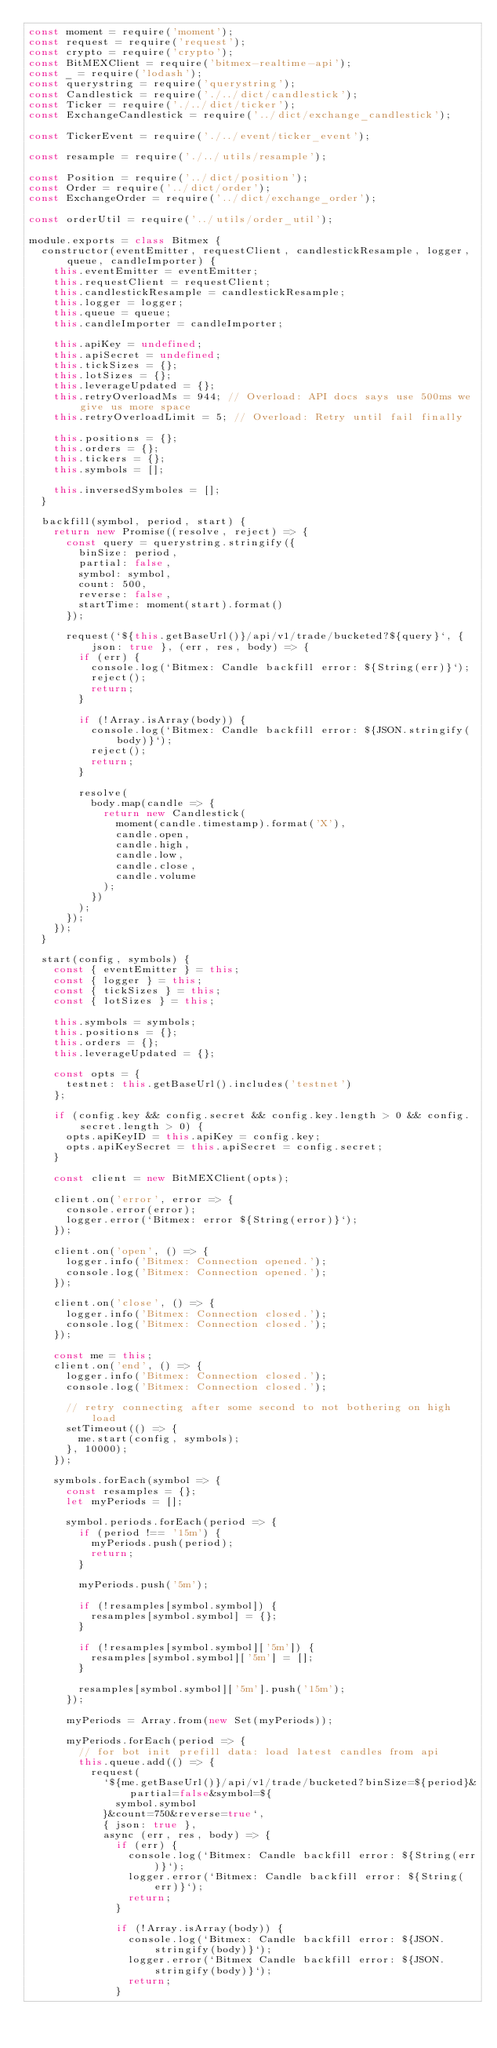Convert code to text. <code><loc_0><loc_0><loc_500><loc_500><_JavaScript_>const moment = require('moment');
const request = require('request');
const crypto = require('crypto');
const BitMEXClient = require('bitmex-realtime-api');
const _ = require('lodash');
const querystring = require('querystring');
const Candlestick = require('./../dict/candlestick');
const Ticker = require('./../dict/ticker');
const ExchangeCandlestick = require('../dict/exchange_candlestick');

const TickerEvent = require('./../event/ticker_event');

const resample = require('./../utils/resample');

const Position = require('../dict/position');
const Order = require('../dict/order');
const ExchangeOrder = require('../dict/exchange_order');

const orderUtil = require('../utils/order_util');

module.exports = class Bitmex {
  constructor(eventEmitter, requestClient, candlestickResample, logger, queue, candleImporter) {
    this.eventEmitter = eventEmitter;
    this.requestClient = requestClient;
    this.candlestickResample = candlestickResample;
    this.logger = logger;
    this.queue = queue;
    this.candleImporter = candleImporter;

    this.apiKey = undefined;
    this.apiSecret = undefined;
    this.tickSizes = {};
    this.lotSizes = {};
    this.leverageUpdated = {};
    this.retryOverloadMs = 944; // Overload: API docs says use 500ms we give us more space
    this.retryOverloadLimit = 5; // Overload: Retry until fail finally

    this.positions = {};
    this.orders = {};
    this.tickers = {};
    this.symbols = [];

    this.inversedSymboles = [];
  }

  backfill(symbol, period, start) {
    return new Promise((resolve, reject) => {
      const query = querystring.stringify({
        binSize: period,
        partial: false,
        symbol: symbol,
        count: 500,
        reverse: false,
        startTime: moment(start).format()
      });

      request(`${this.getBaseUrl()}/api/v1/trade/bucketed?${query}`, { json: true }, (err, res, body) => {
        if (err) {
          console.log(`Bitmex: Candle backfill error: ${String(err)}`);
          reject();
          return;
        }

        if (!Array.isArray(body)) {
          console.log(`Bitmex: Candle backfill error: ${JSON.stringify(body)}`);
          reject();
          return;
        }

        resolve(
          body.map(candle => {
            return new Candlestick(
              moment(candle.timestamp).format('X'),
              candle.open,
              candle.high,
              candle.low,
              candle.close,
              candle.volume
            );
          })
        );
      });
    });
  }

  start(config, symbols) {
    const { eventEmitter } = this;
    const { logger } = this;
    const { tickSizes } = this;
    const { lotSizes } = this;

    this.symbols = symbols;
    this.positions = {};
    this.orders = {};
    this.leverageUpdated = {};

    const opts = {
      testnet: this.getBaseUrl().includes('testnet')
    };

    if (config.key && config.secret && config.key.length > 0 && config.secret.length > 0) {
      opts.apiKeyID = this.apiKey = config.key;
      opts.apiKeySecret = this.apiSecret = config.secret;
    }

    const client = new BitMEXClient(opts);

    client.on('error', error => {
      console.error(error);
      logger.error(`Bitmex: error ${String(error)}`);
    });

    client.on('open', () => {
      logger.info('Bitmex: Connection opened.');
      console.log('Bitmex: Connection opened.');
    });

    client.on('close', () => {
      logger.info('Bitmex: Connection closed.');
      console.log('Bitmex: Connection closed.');
    });

    const me = this;
    client.on('end', () => {
      logger.info('Bitmex: Connection closed.');
      console.log('Bitmex: Connection closed.');

      // retry connecting after some second to not bothering on high load
      setTimeout(() => {
        me.start(config, symbols);
      }, 10000);
    });

    symbols.forEach(symbol => {
      const resamples = {};
      let myPeriods = [];

      symbol.periods.forEach(period => {
        if (period !== '15m') {
          myPeriods.push(period);
          return;
        }

        myPeriods.push('5m');

        if (!resamples[symbol.symbol]) {
          resamples[symbol.symbol] = {};
        }

        if (!resamples[symbol.symbol]['5m']) {
          resamples[symbol.symbol]['5m'] = [];
        }

        resamples[symbol.symbol]['5m'].push('15m');
      });

      myPeriods = Array.from(new Set(myPeriods));

      myPeriods.forEach(period => {
        // for bot init prefill data: load latest candles from api
        this.queue.add(() => {
          request(
            `${me.getBaseUrl()}/api/v1/trade/bucketed?binSize=${period}&partial=false&symbol=${
              symbol.symbol
            }&count=750&reverse=true`,
            { json: true },
            async (err, res, body) => {
              if (err) {
                console.log(`Bitmex: Candle backfill error: ${String(err)}`);
                logger.error(`Bitmex: Candle backfill error: ${String(err)}`);
                return;
              }

              if (!Array.isArray(body)) {
                console.log(`Bitmex: Candle backfill error: ${JSON.stringify(body)}`);
                logger.error(`Bitmex Candle backfill error: ${JSON.stringify(body)}`);
                return;
              }
</code> 